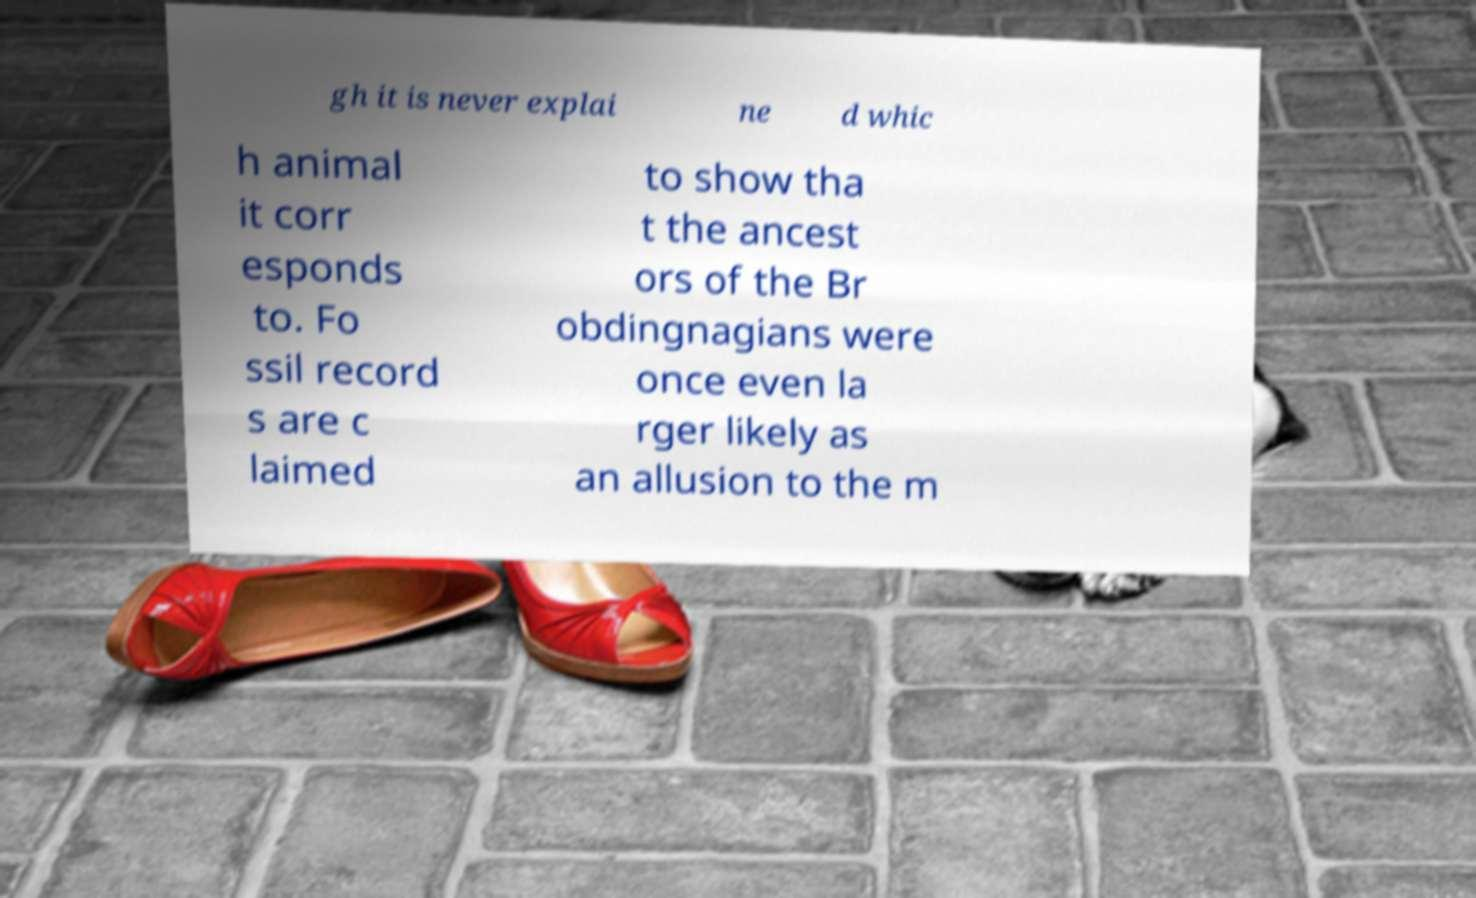Could you assist in decoding the text presented in this image and type it out clearly? gh it is never explai ne d whic h animal it corr esponds to. Fo ssil record s are c laimed to show tha t the ancest ors of the Br obdingnagians were once even la rger likely as an allusion to the m 